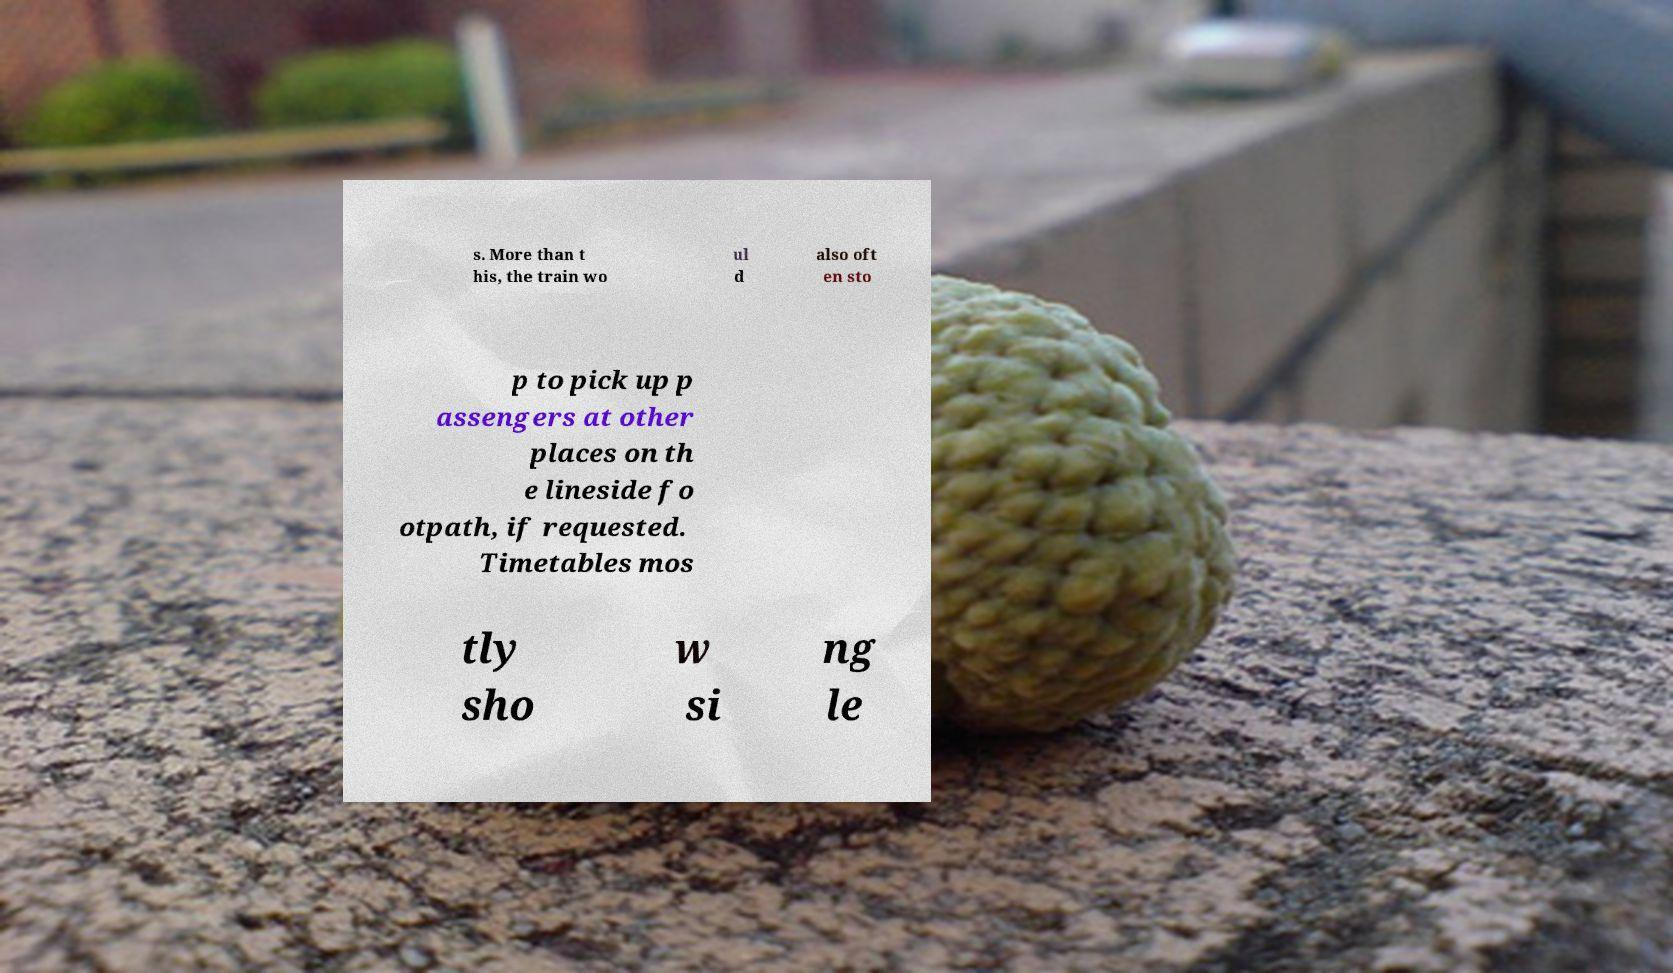There's text embedded in this image that I need extracted. Can you transcribe it verbatim? s. More than t his, the train wo ul d also oft en sto p to pick up p assengers at other places on th e lineside fo otpath, if requested. Timetables mos tly sho w si ng le 